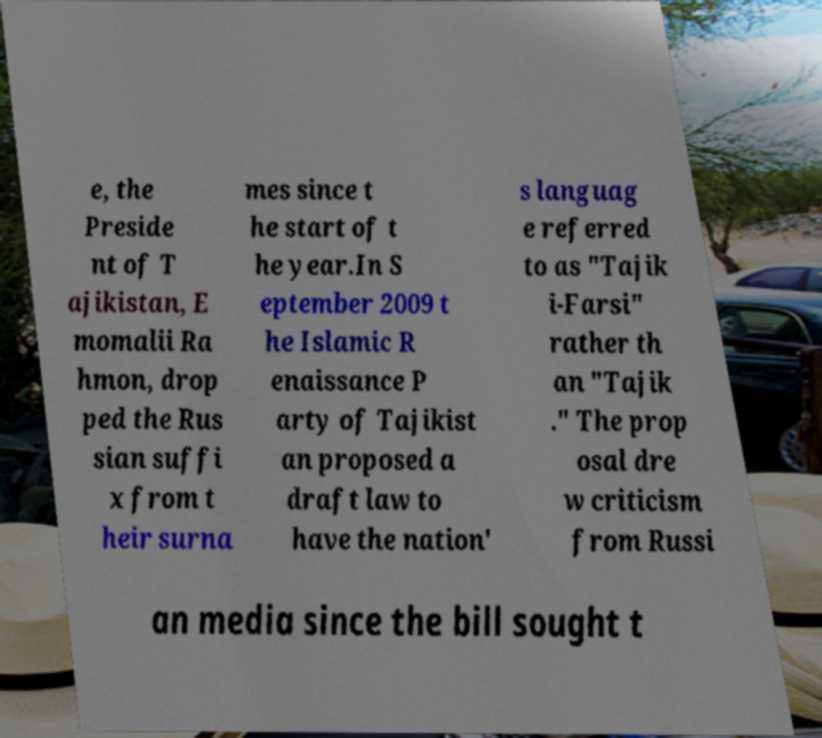I need the written content from this picture converted into text. Can you do that? e, the Preside nt of T ajikistan, E momalii Ra hmon, drop ped the Rus sian suffi x from t heir surna mes since t he start of t he year.In S eptember 2009 t he Islamic R enaissance P arty of Tajikist an proposed a draft law to have the nation' s languag e referred to as "Tajik i-Farsi" rather th an "Tajik ." The prop osal dre w criticism from Russi an media since the bill sought t 